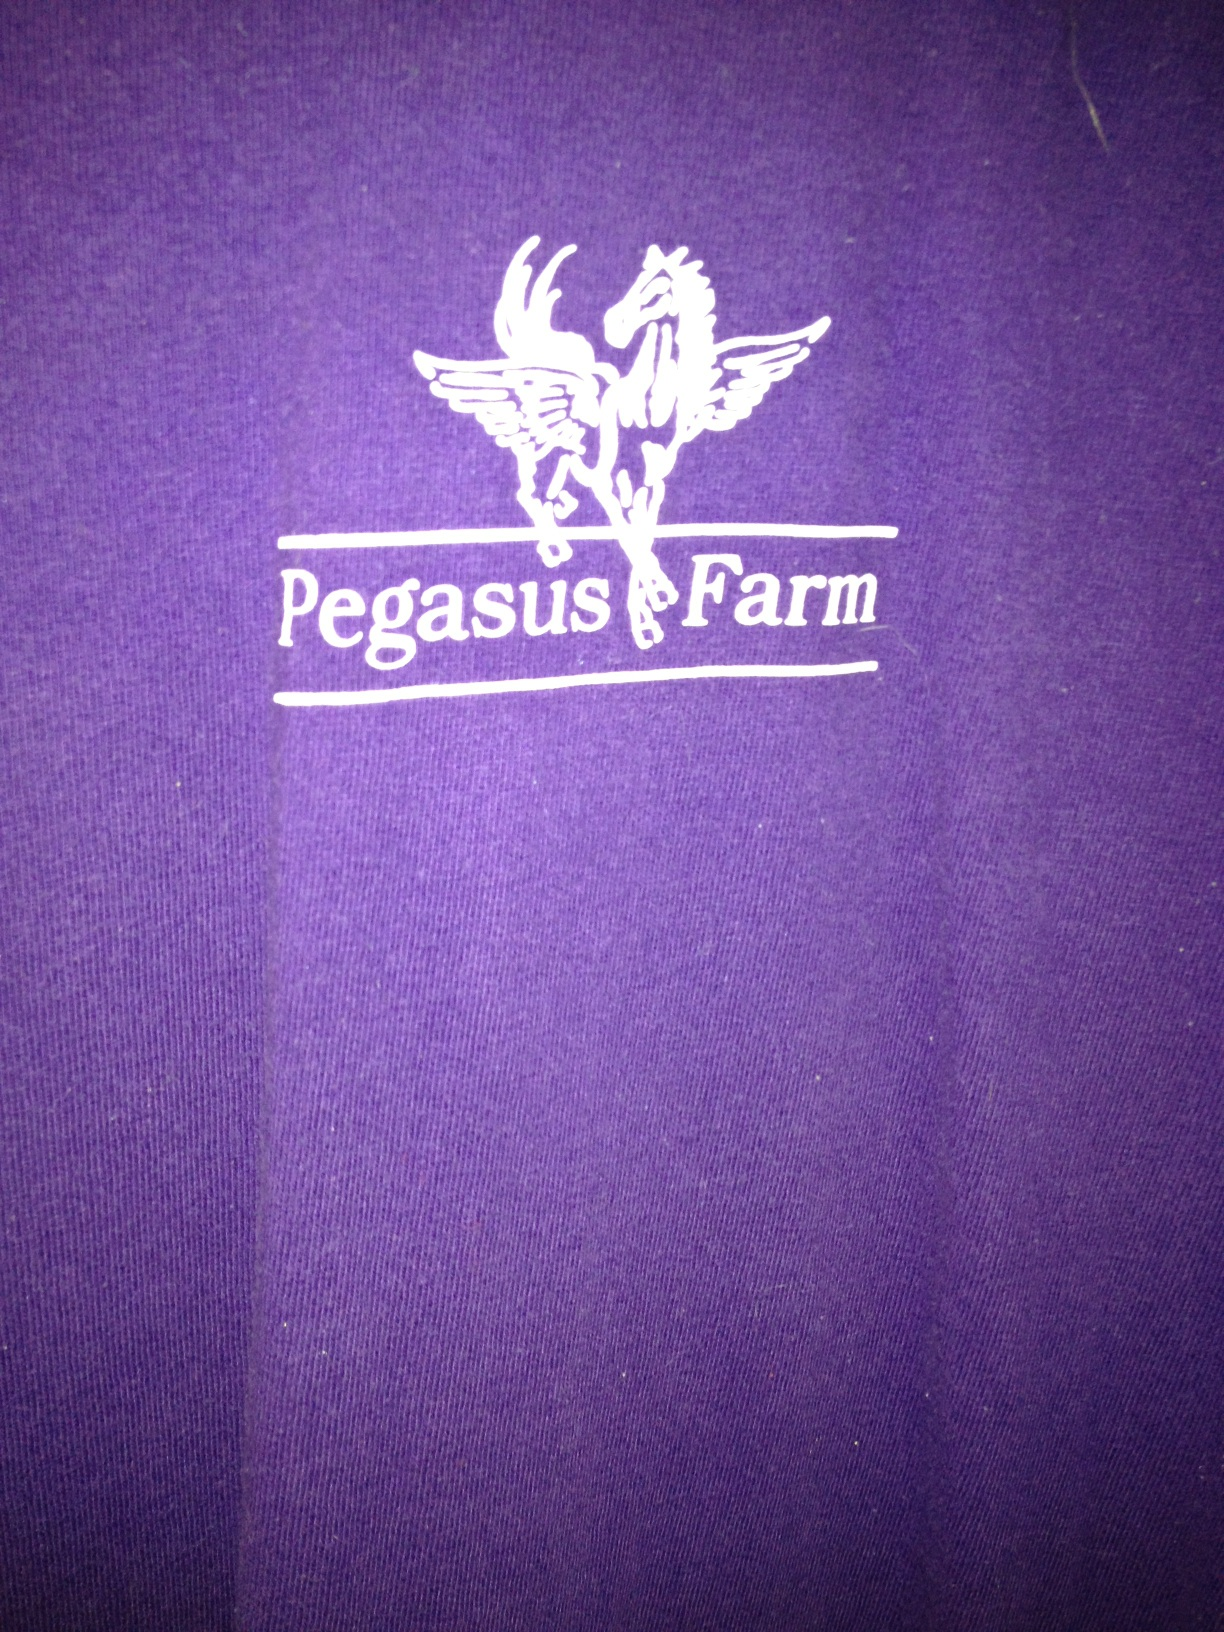Can you guess why I might be wearing this shirt? Given the unique 'Pegasus Farm' graphic, it might be a shirt from a farm or an organization with the same name, perhaps indicating a personal affiliation or support for a place that may be related to equestrian activities or animal welfare. 